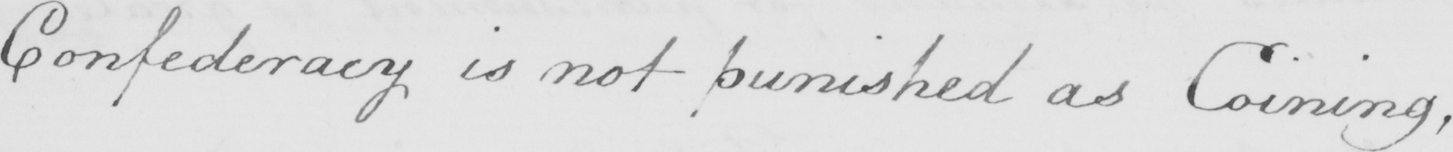Transcribe the text shown in this historical manuscript line. Confederacy is not punished as Coining , 